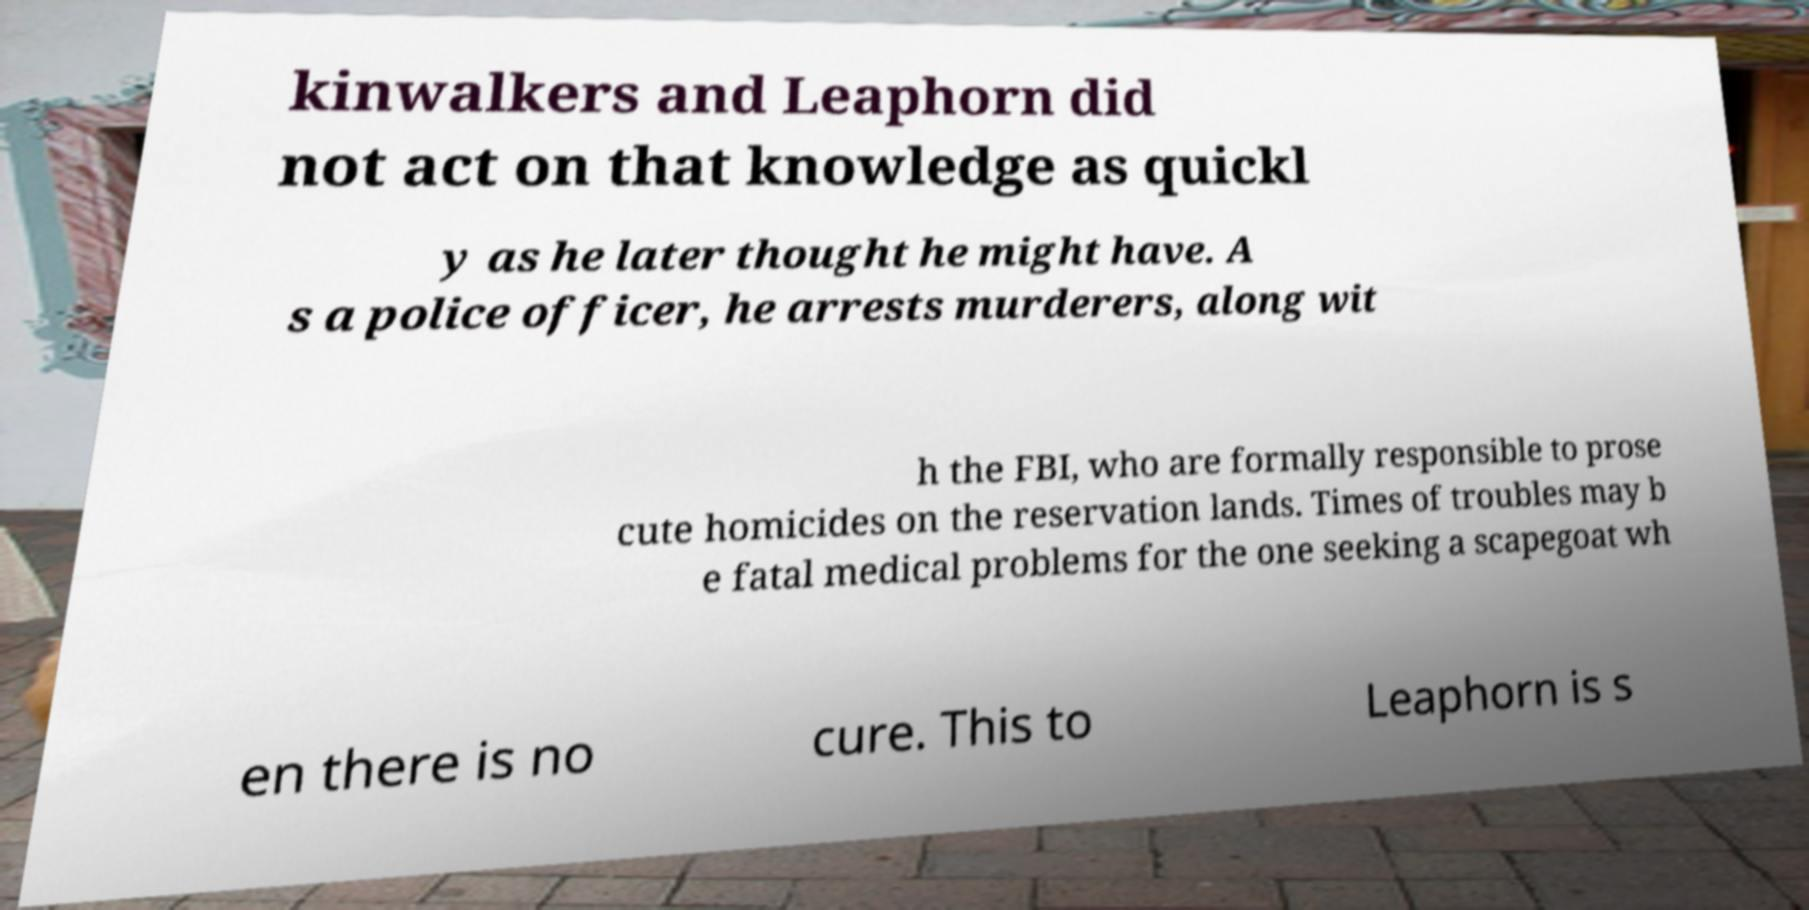Can you accurately transcribe the text from the provided image for me? kinwalkers and Leaphorn did not act on that knowledge as quickl y as he later thought he might have. A s a police officer, he arrests murderers, along wit h the FBI, who are formally responsible to prose cute homicides on the reservation lands. Times of troubles may b e fatal medical problems for the one seeking a scapegoat wh en there is no cure. This to Leaphorn is s 